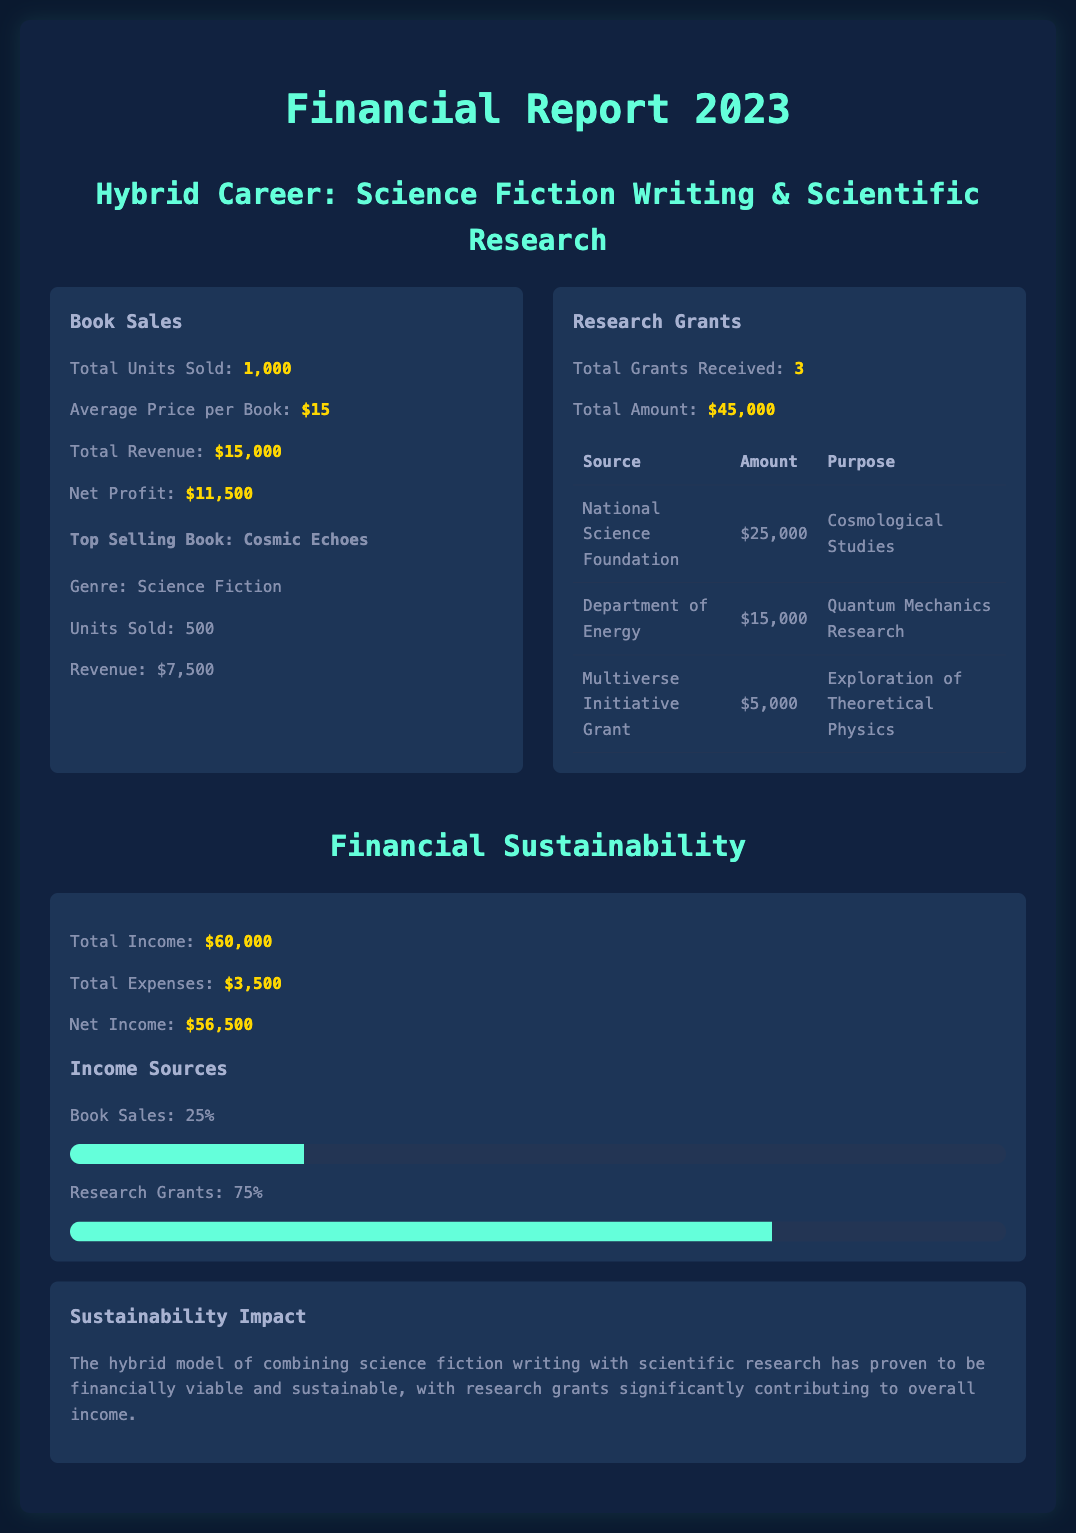What is the total revenue from book sales? The total revenue from book sales is stated directly in the document, which is $15,000.
Answer: $15,000 How many units of the top-selling book were sold? The document provides the number of units sold for the top-selling book, "Cosmic Echoes," which is 500 units.
Answer: 500 What is the amount received from the National Science Foundation? The document lists the amount received from the National Science Foundation, which is $25,000.
Answer: $25,000 What percentage of total income comes from research grants? The document indicates that research grants account for 75% of the total income.
Answer: 75% What is the total number of grants received? The total number of grants mentioned in the report is 3.
Answer: 3 What is the net profit from book sales? The document states that the net profit from book sales is $11,500.
Answer: $11,500 What is the total amount of expenses? The total expenses listed in the financial report are $3,500.
Answer: $3,500 What is the main conclusion regarding financial sustainability? The conclusion about financial sustainability indicates that the hybrid model is viable and sustainable, with significant contribution from research grants.
Answer: financially viable and sustainable What is the total amount of research grants received? The total amount of research grants received is $45,000, as stated in the document.
Answer: $45,000 